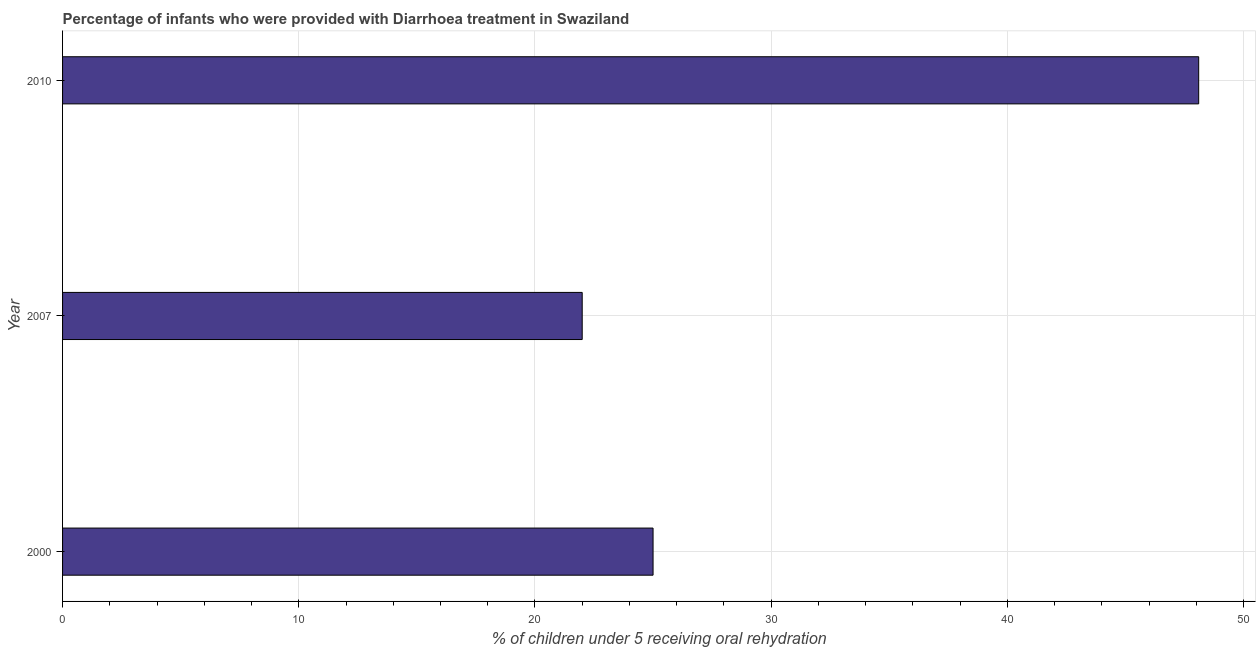Does the graph contain grids?
Provide a short and direct response. Yes. What is the title of the graph?
Keep it short and to the point. Percentage of infants who were provided with Diarrhoea treatment in Swaziland. What is the label or title of the X-axis?
Your response must be concise. % of children under 5 receiving oral rehydration. What is the label or title of the Y-axis?
Ensure brevity in your answer.  Year. What is the percentage of children who were provided with treatment diarrhoea in 2010?
Make the answer very short. 48.1. Across all years, what is the maximum percentage of children who were provided with treatment diarrhoea?
Your answer should be compact. 48.1. Across all years, what is the minimum percentage of children who were provided with treatment diarrhoea?
Offer a very short reply. 22. In which year was the percentage of children who were provided with treatment diarrhoea maximum?
Ensure brevity in your answer.  2010. In which year was the percentage of children who were provided with treatment diarrhoea minimum?
Ensure brevity in your answer.  2007. What is the sum of the percentage of children who were provided with treatment diarrhoea?
Offer a very short reply. 95.1. What is the difference between the percentage of children who were provided with treatment diarrhoea in 2000 and 2007?
Keep it short and to the point. 3. What is the average percentage of children who were provided with treatment diarrhoea per year?
Your response must be concise. 31.7. In how many years, is the percentage of children who were provided with treatment diarrhoea greater than 38 %?
Keep it short and to the point. 1. What is the ratio of the percentage of children who were provided with treatment diarrhoea in 2007 to that in 2010?
Offer a very short reply. 0.46. Is the difference between the percentage of children who were provided with treatment diarrhoea in 2000 and 2007 greater than the difference between any two years?
Ensure brevity in your answer.  No. What is the difference between the highest and the second highest percentage of children who were provided with treatment diarrhoea?
Your answer should be compact. 23.1. Is the sum of the percentage of children who were provided with treatment diarrhoea in 2000 and 2010 greater than the maximum percentage of children who were provided with treatment diarrhoea across all years?
Keep it short and to the point. Yes. What is the difference between the highest and the lowest percentage of children who were provided with treatment diarrhoea?
Your response must be concise. 26.1. How many bars are there?
Your response must be concise. 3. Are all the bars in the graph horizontal?
Make the answer very short. Yes. What is the difference between two consecutive major ticks on the X-axis?
Keep it short and to the point. 10. What is the % of children under 5 receiving oral rehydration in 2000?
Make the answer very short. 25. What is the % of children under 5 receiving oral rehydration in 2010?
Ensure brevity in your answer.  48.1. What is the difference between the % of children under 5 receiving oral rehydration in 2000 and 2010?
Keep it short and to the point. -23.1. What is the difference between the % of children under 5 receiving oral rehydration in 2007 and 2010?
Provide a short and direct response. -26.1. What is the ratio of the % of children under 5 receiving oral rehydration in 2000 to that in 2007?
Your response must be concise. 1.14. What is the ratio of the % of children under 5 receiving oral rehydration in 2000 to that in 2010?
Your response must be concise. 0.52. What is the ratio of the % of children under 5 receiving oral rehydration in 2007 to that in 2010?
Give a very brief answer. 0.46. 